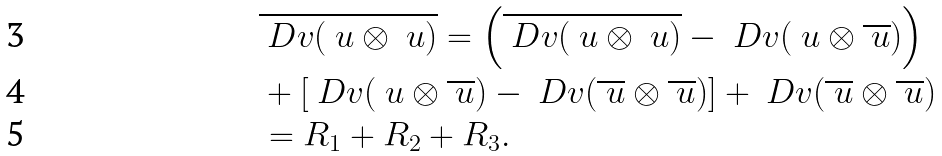<formula> <loc_0><loc_0><loc_500><loc_500>& \overline { \ D v ( \ u \otimes \ u ) } = \left ( \overline { \ D v ( \ u \otimes \ u ) } - \ D v ( \ u \otimes \overline { \ u } ) \right ) \\ & + \left [ \ D v ( \ u \otimes \overline { \ u } ) - \ D v ( \overline { \ u } \otimes \overline { \ u } ) \right ] + \ D v ( \overline { \ u } \otimes \overline { \ u } ) \\ & = R _ { 1 } + R _ { 2 } + R _ { 3 } .</formula> 